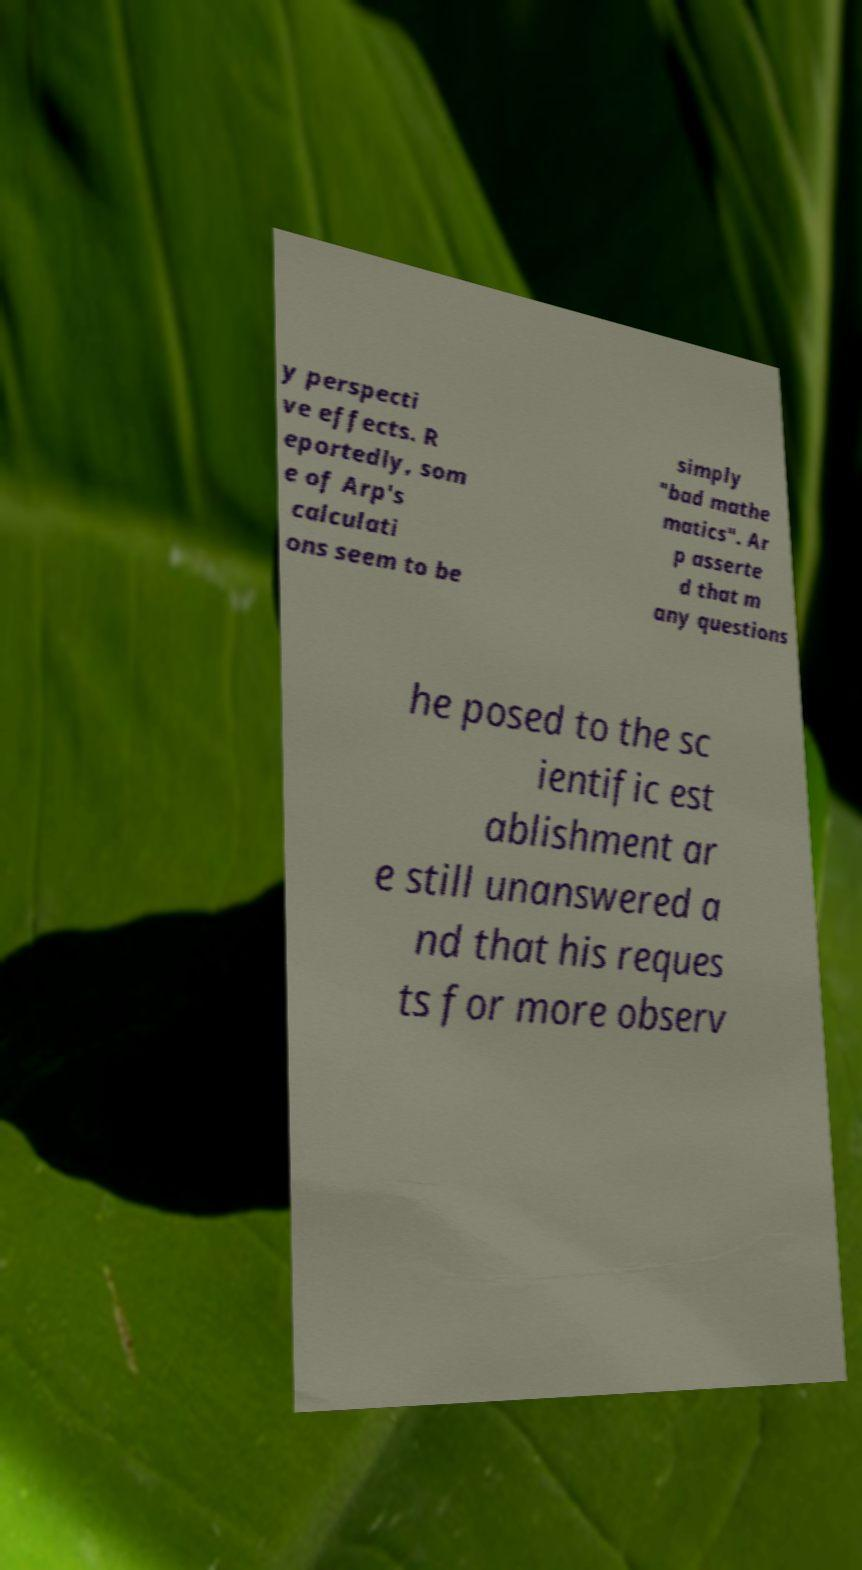What messages or text are displayed in this image? I need them in a readable, typed format. y perspecti ve effects. R eportedly, som e of Arp's calculati ons seem to be simply "bad mathe matics". Ar p asserte d that m any questions he posed to the sc ientific est ablishment ar e still unanswered a nd that his reques ts for more observ 